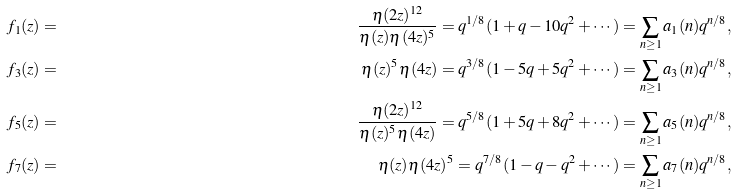<formula> <loc_0><loc_0><loc_500><loc_500>f _ { 1 } ( z ) & = & \frac { \eta ( 2 z ) ^ { 1 2 } } { \eta ( z ) \eta ( 4 z ) ^ { 5 } } = q ^ { 1 / 8 } ( 1 + q - 1 0 q ^ { 2 } + \cdots ) = \sum _ { n \geq 1 } a _ { 1 } ( n ) q ^ { n / 8 } , \\ f _ { 3 } ( z ) & = & \eta ( z ) ^ { 5 } \eta ( 4 z ) = q ^ { 3 / 8 } ( 1 - 5 q + 5 q ^ { 2 } + \cdots ) = \sum _ { n \geq 1 } a _ { 3 } ( n ) q ^ { n / 8 } , \\ f _ { 5 } ( z ) & = & \frac { \eta ( 2 z ) ^ { 1 2 } } { \eta ( z ) ^ { 5 } \eta ( 4 z ) } = q ^ { 5 / 8 } ( 1 + 5 q + 8 q ^ { 2 } + \cdots ) = \sum _ { n \geq 1 } a _ { 5 } ( n ) q ^ { n / 8 } , \\ f _ { 7 } ( z ) & = & \eta ( z ) \eta ( 4 z ) ^ { 5 } = q ^ { 7 / 8 } ( 1 - q - q ^ { 2 } + \cdots ) = \sum _ { n \geq 1 } a _ { 7 } ( n ) q ^ { n / 8 } ,</formula> 